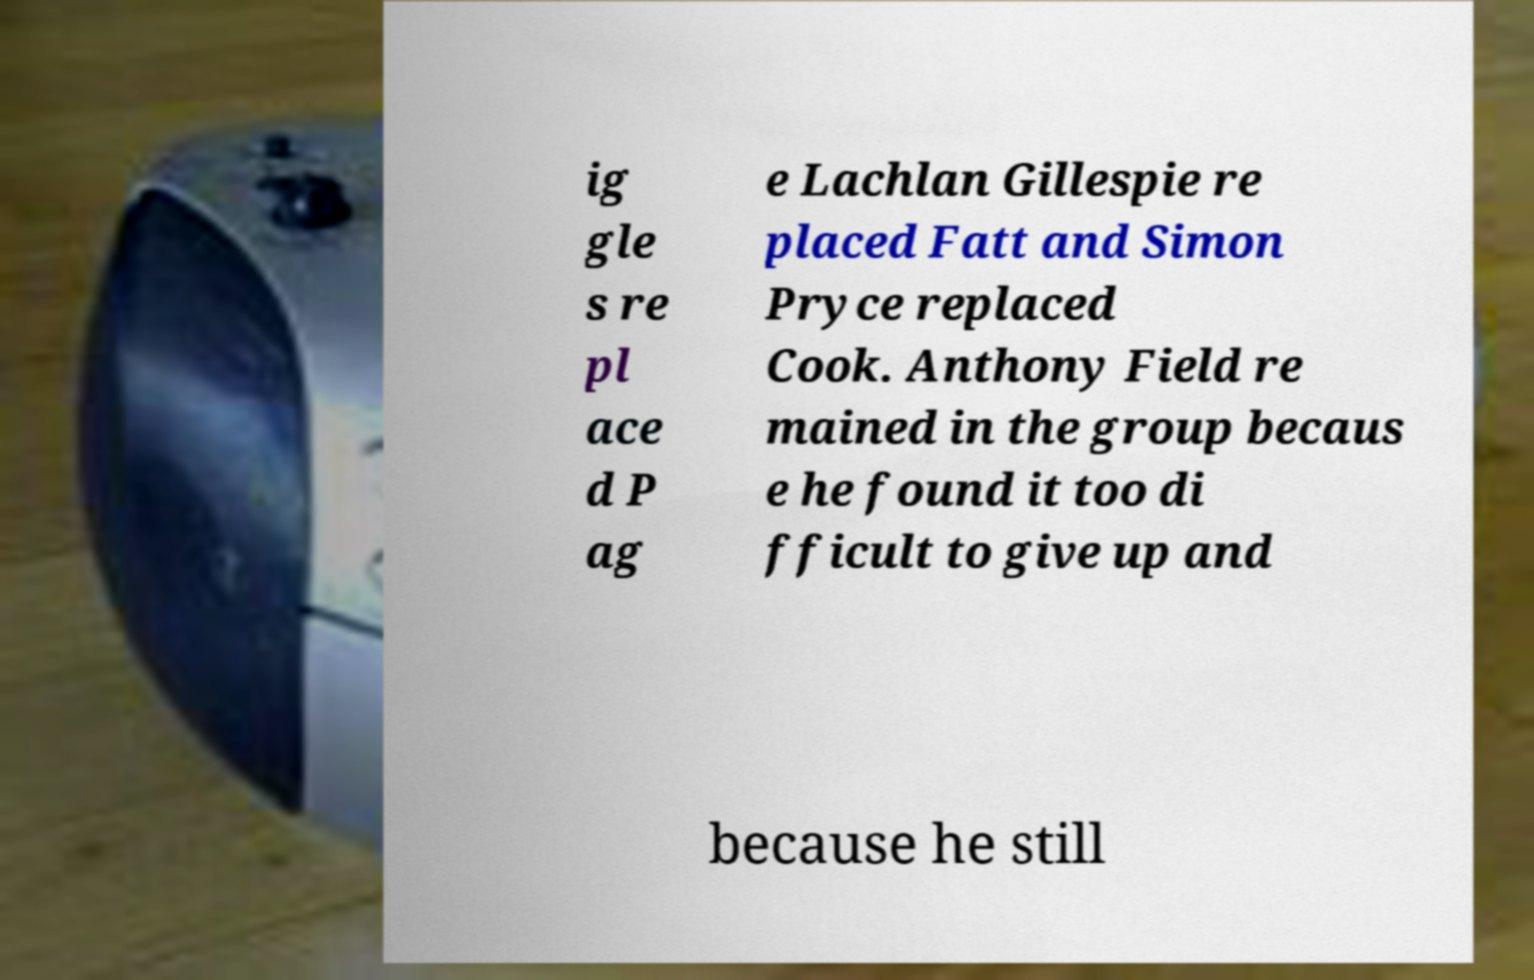I need the written content from this picture converted into text. Can you do that? ig gle s re pl ace d P ag e Lachlan Gillespie re placed Fatt and Simon Pryce replaced Cook. Anthony Field re mained in the group becaus e he found it too di fficult to give up and because he still 